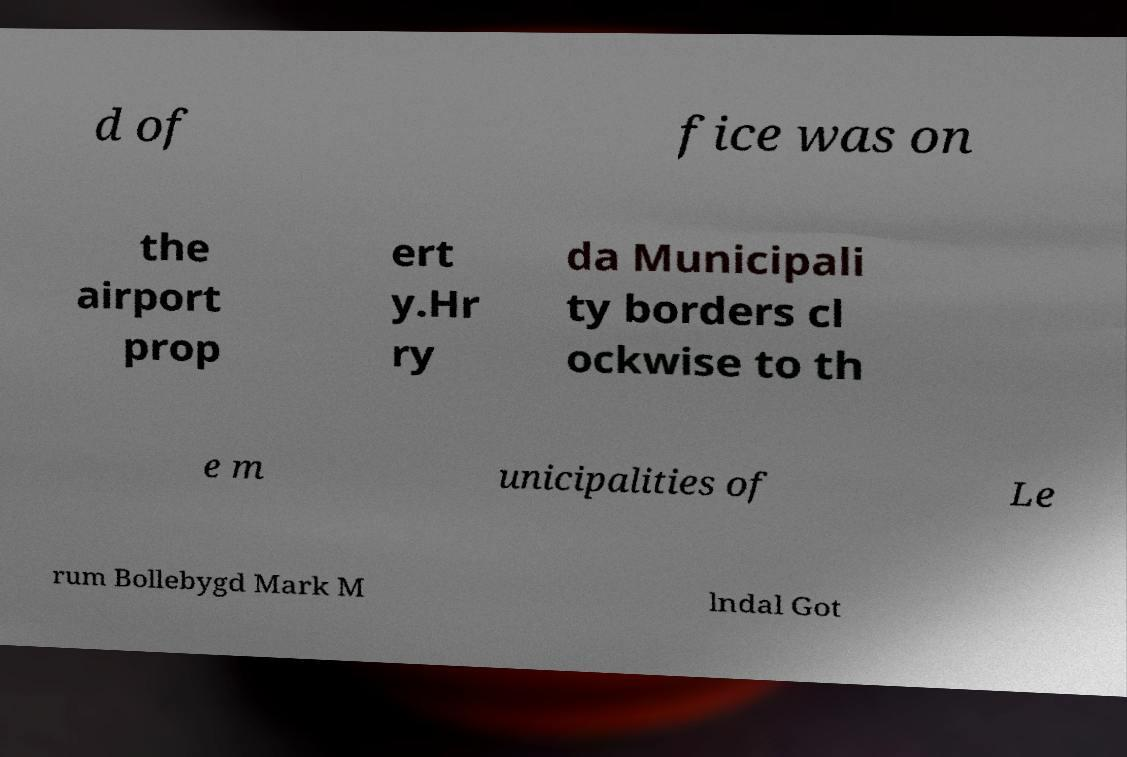I need the written content from this picture converted into text. Can you do that? d of fice was on the airport prop ert y.Hr ry da Municipali ty borders cl ockwise to th e m unicipalities of Le rum Bollebygd Mark M lndal Got 